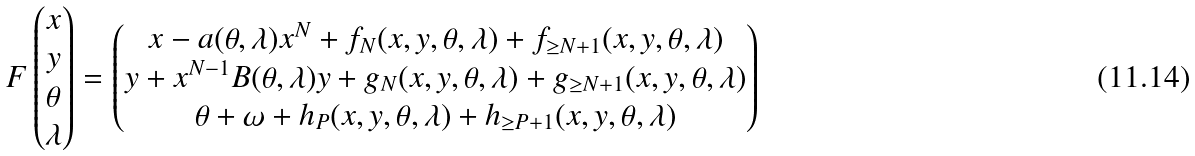Convert formula to latex. <formula><loc_0><loc_0><loc_500><loc_500>F \begin{pmatrix} x \\ y \\ \theta \\ \lambda \end{pmatrix} = \begin{pmatrix} x - a ( \theta , \lambda ) x ^ { N } + f _ { N } ( x , y , \theta , \lambda ) + f _ { \geq N + 1 } ( x , y , \theta , \lambda ) \\ y + x ^ { N - 1 } B ( \theta , \lambda ) y + g _ { N } ( x , y , \theta , \lambda ) + g _ { \geq N + 1 } ( x , y , \theta , \lambda ) \\ \theta + \omega + h _ { P } ( x , y , \theta , \lambda ) + h _ { \geq P + 1 } ( x , y , \theta , \lambda ) \end{pmatrix}</formula> 